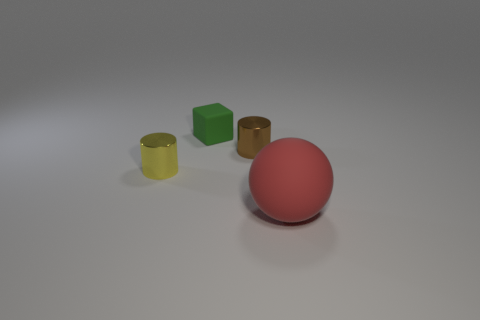There is a metallic cylinder that is the same size as the brown object; what is its color?
Ensure brevity in your answer.  Yellow. What number of rubber things are small yellow cylinders or big red objects?
Give a very brief answer. 1. How many small things are behind the yellow cylinder and in front of the tiny brown shiny cylinder?
Offer a very short reply. 0. Are there any other things that have the same shape as the green thing?
Make the answer very short. No. How many other things are the same size as the rubber sphere?
Ensure brevity in your answer.  0. Does the metal thing that is on the right side of the matte block have the same size as the object behind the small brown cylinder?
Give a very brief answer. Yes. How many objects are big gray rubber cubes or things that are to the left of the red matte ball?
Your answer should be very brief. 3. There is a rubber thing that is right of the tiny green block; what is its size?
Your answer should be very brief. Large. Are there fewer red matte things that are behind the yellow metallic object than brown things behind the large red matte thing?
Give a very brief answer. Yes. What material is the object that is in front of the tiny brown cylinder and right of the green block?
Offer a terse response. Rubber. 